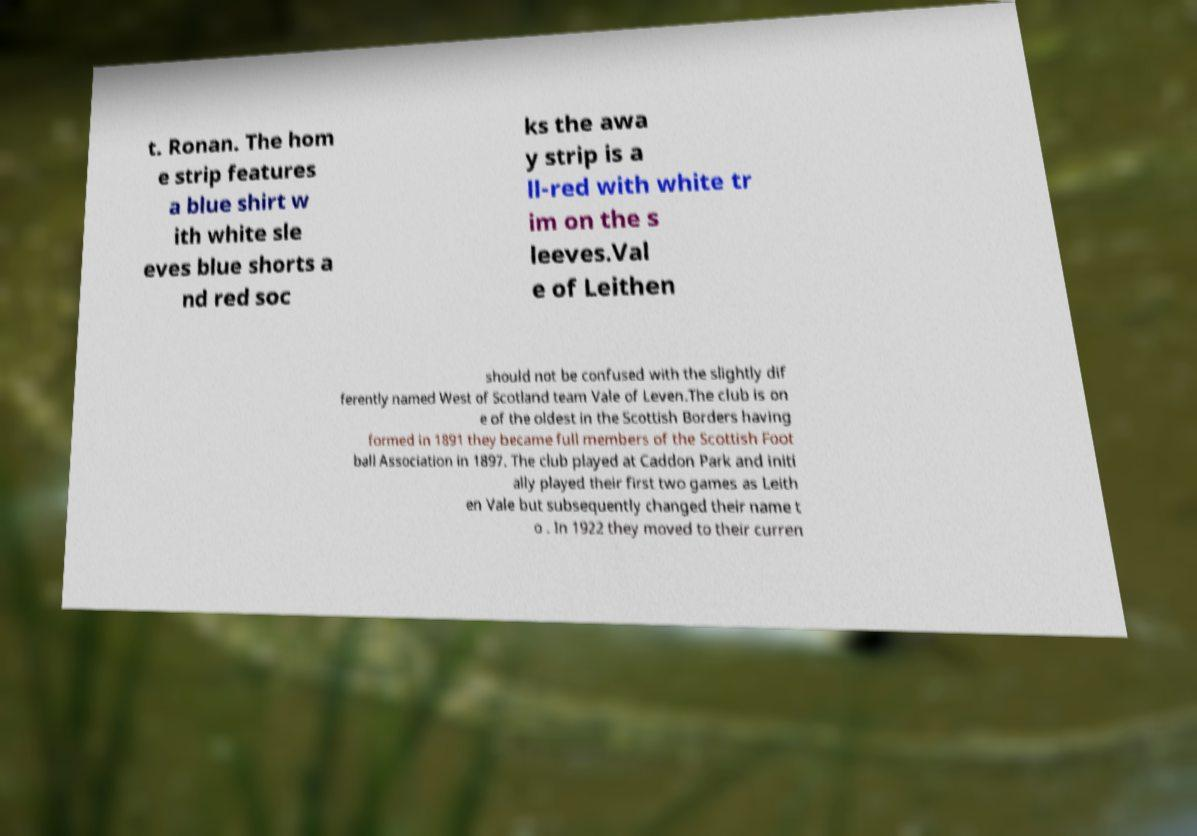Please read and relay the text visible in this image. What does it say? t. Ronan. The hom e strip features a blue shirt w ith white sle eves blue shorts a nd red soc ks the awa y strip is a ll-red with white tr im on the s leeves.Val e of Leithen should not be confused with the slightly dif ferently named West of Scotland team Vale of Leven.The club is on e of the oldest in the Scottish Borders having formed in 1891 they became full members of the Scottish Foot ball Association in 1897. The club played at Caddon Park and initi ally played their first two games as Leith en Vale but subsequently changed their name t o . In 1922 they moved to their curren 